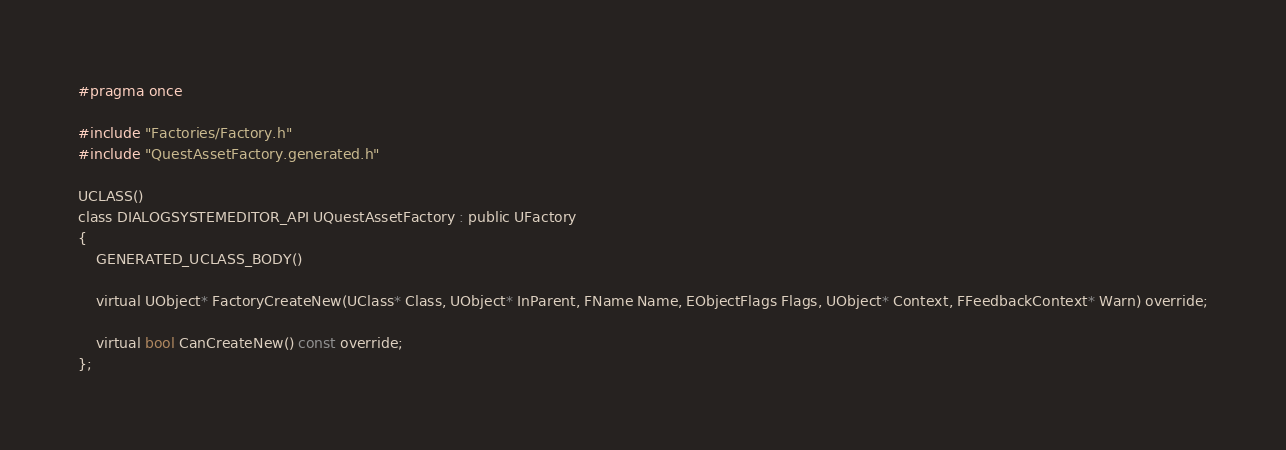Convert code to text. <code><loc_0><loc_0><loc_500><loc_500><_C_>#pragma once

#include "Factories/Factory.h"
#include "QuestAssetFactory.generated.h"

UCLASS()
class DIALOGSYSTEMEDITOR_API UQuestAssetFactory : public UFactory
{
	GENERATED_UCLASS_BODY()

	virtual UObject* FactoryCreateNew(UClass* Class, UObject* InParent, FName Name, EObjectFlags Flags, UObject* Context, FFeedbackContext* Warn) override;

	virtual bool CanCreateNew() const override;
};</code> 